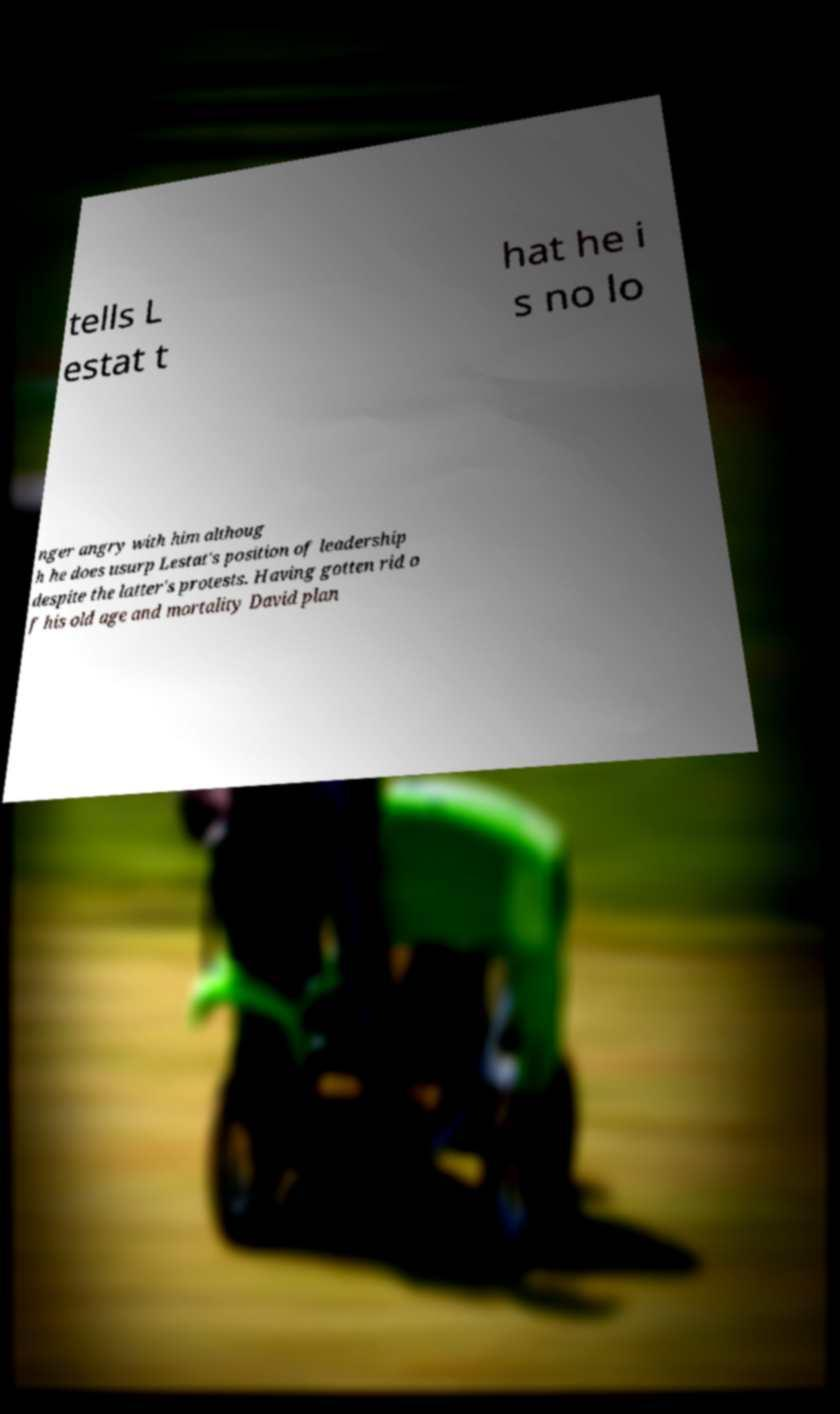Can you read and provide the text displayed in the image?This photo seems to have some interesting text. Can you extract and type it out for me? tells L estat t hat he i s no lo nger angry with him althoug h he does usurp Lestat's position of leadership despite the latter's protests. Having gotten rid o f his old age and mortality David plan 